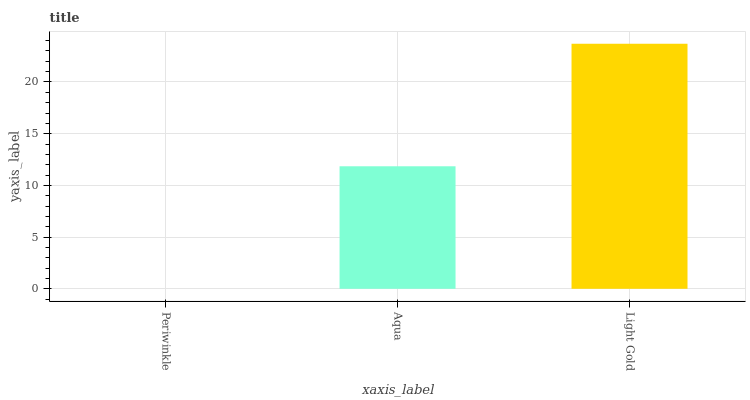Is Aqua the minimum?
Answer yes or no. No. Is Aqua the maximum?
Answer yes or no. No. Is Aqua greater than Periwinkle?
Answer yes or no. Yes. Is Periwinkle less than Aqua?
Answer yes or no. Yes. Is Periwinkle greater than Aqua?
Answer yes or no. No. Is Aqua less than Periwinkle?
Answer yes or no. No. Is Aqua the high median?
Answer yes or no. Yes. Is Aqua the low median?
Answer yes or no. Yes. Is Periwinkle the high median?
Answer yes or no. No. Is Periwinkle the low median?
Answer yes or no. No. 